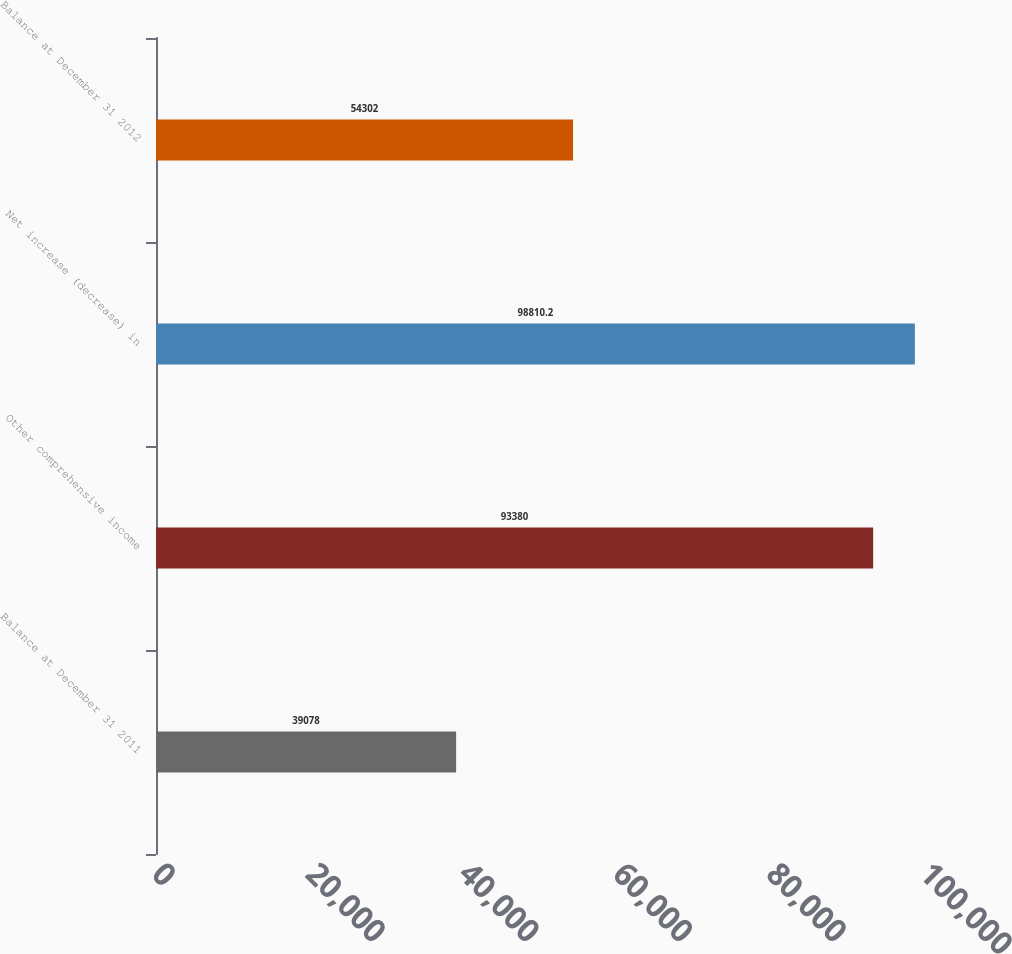Convert chart. <chart><loc_0><loc_0><loc_500><loc_500><bar_chart><fcel>Balance at December 31 2011<fcel>Other comprehensive income<fcel>Net increase (decrease) in<fcel>Balance at December 31 2012<nl><fcel>39078<fcel>93380<fcel>98810.2<fcel>54302<nl></chart> 